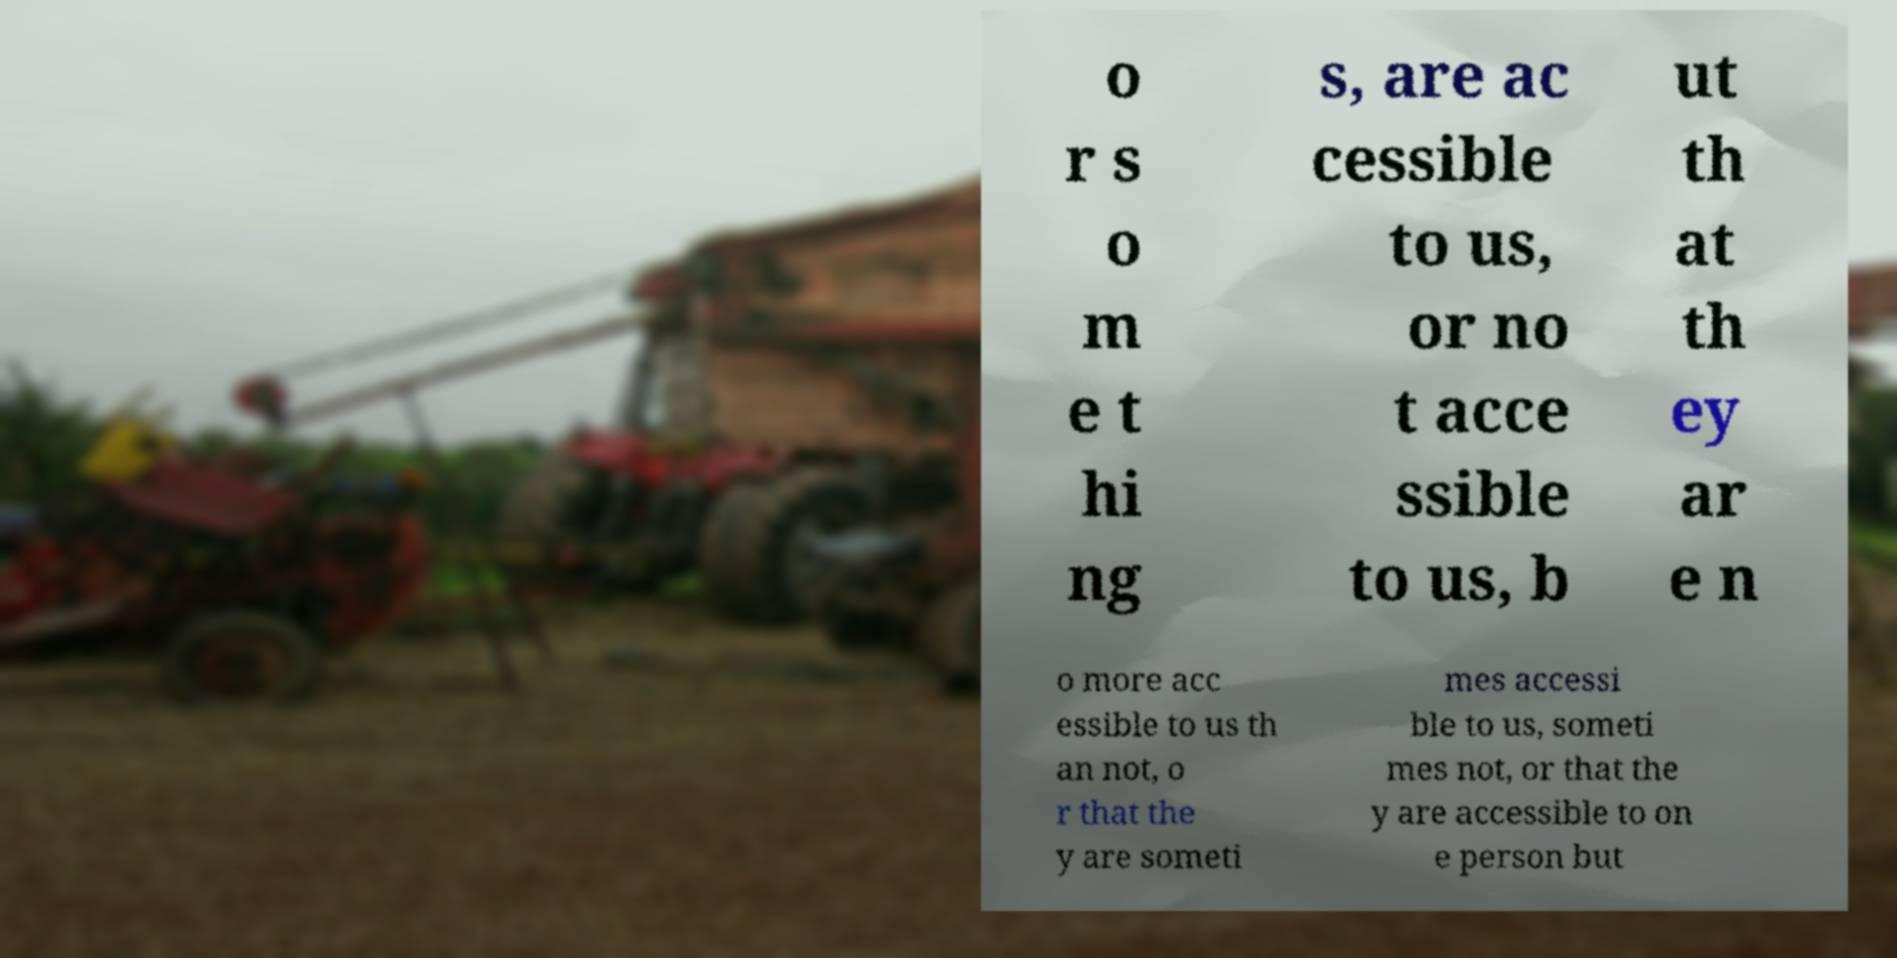Can you read and provide the text displayed in the image?This photo seems to have some interesting text. Can you extract and type it out for me? o r s o m e t hi ng s, are ac cessible to us, or no t acce ssible to us, b ut th at th ey ar e n o more acc essible to us th an not, o r that the y are someti mes accessi ble to us, someti mes not, or that the y are accessible to on e person but 